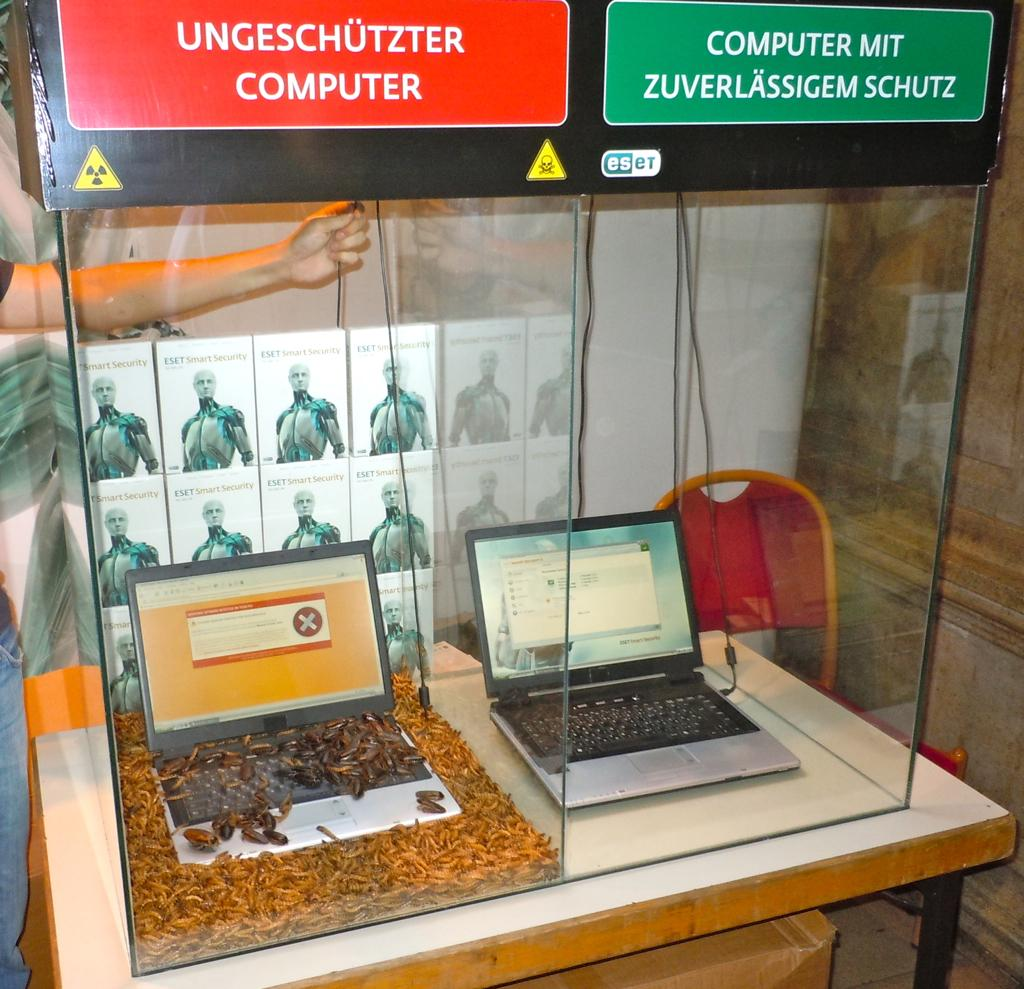What objects are inside the glass in the image? There are laptops in the glass. What type of furniture is present in the image? There is a table and a chair in the image. What type of cork can be seen on the table in the image? There is no cork present on the table in the image. What type of pot is visible on the chair in the image? There is no pot visible on the chair in the image. 